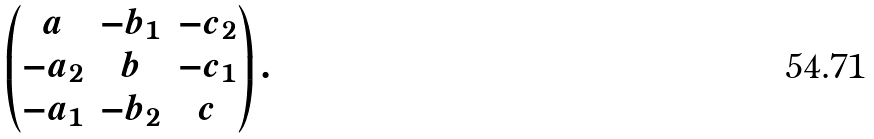<formula> <loc_0><loc_0><loc_500><loc_500>\begin{pmatrix} a & - b _ { 1 } & - c _ { 2 } \\ - a _ { 2 } & b & - c _ { 1 } \\ - a _ { 1 } & - b _ { 2 } & c \end{pmatrix} .</formula> 